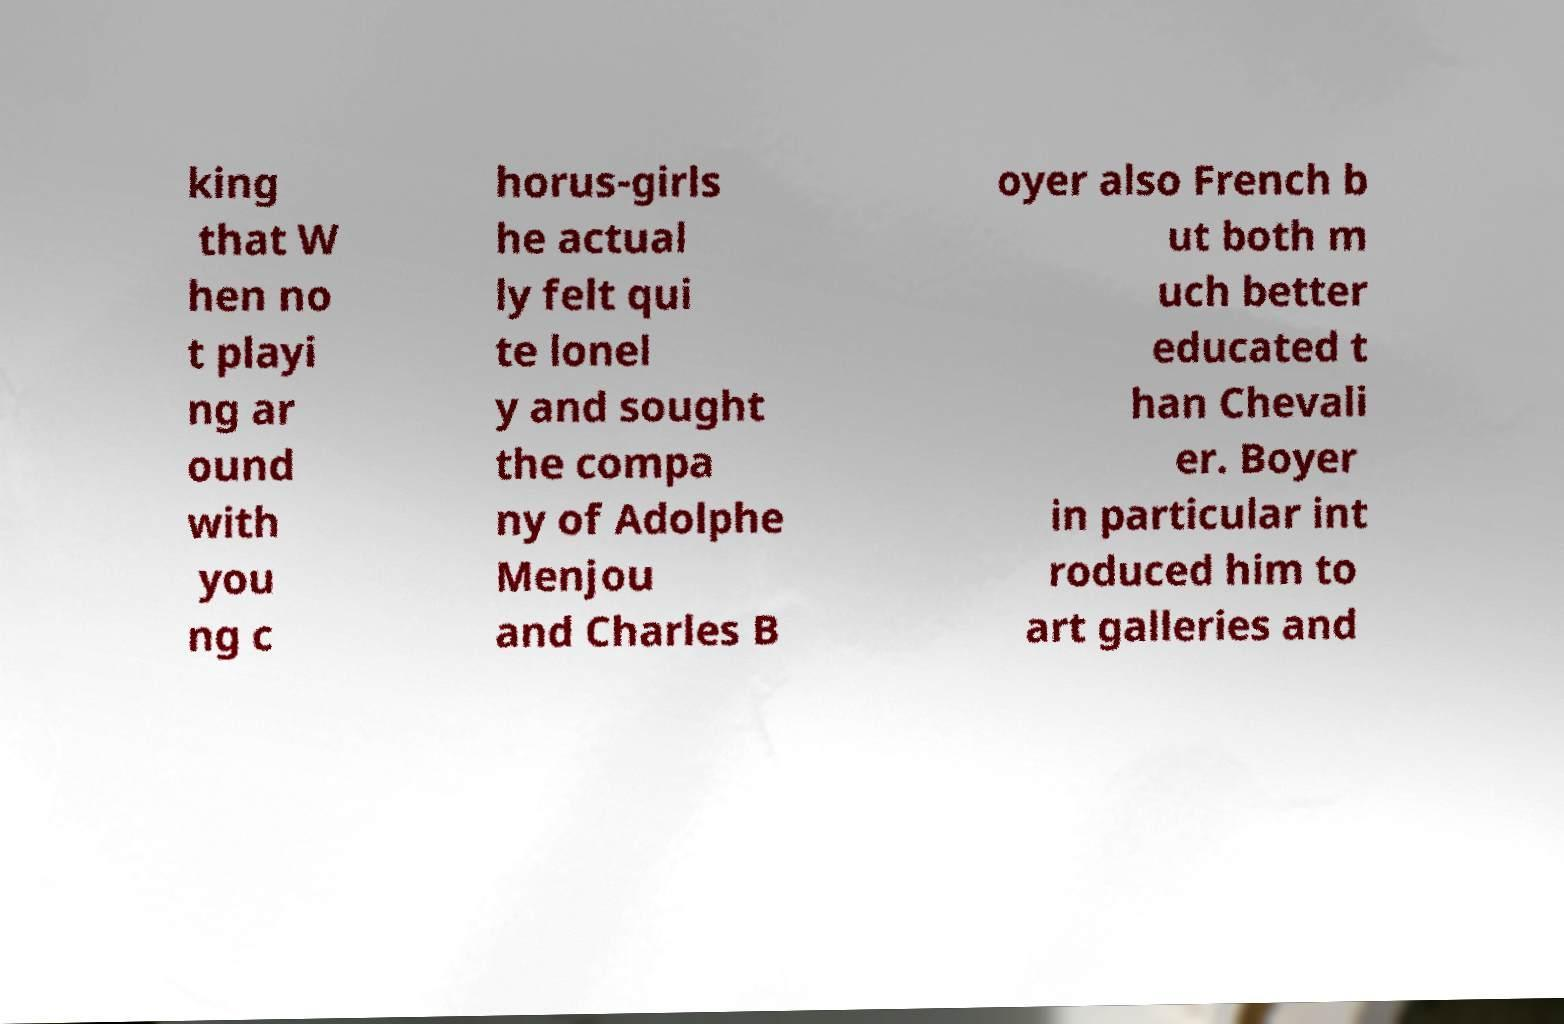There's text embedded in this image that I need extracted. Can you transcribe it verbatim? king that W hen no t playi ng ar ound with you ng c horus-girls he actual ly felt qui te lonel y and sought the compa ny of Adolphe Menjou and Charles B oyer also French b ut both m uch better educated t han Chevali er. Boyer in particular int roduced him to art galleries and 